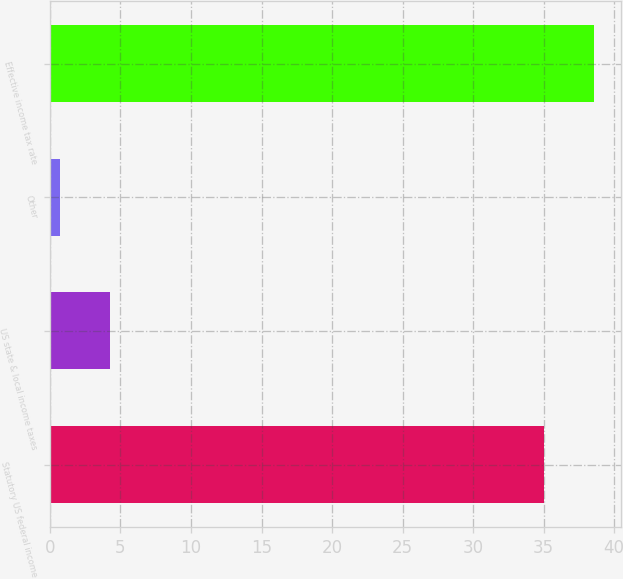Convert chart. <chart><loc_0><loc_0><loc_500><loc_500><bar_chart><fcel>Statutory US federal income<fcel>US state & local income taxes<fcel>Other<fcel>Effective income tax rate<nl><fcel>35<fcel>4.26<fcel>0.7<fcel>38.56<nl></chart> 